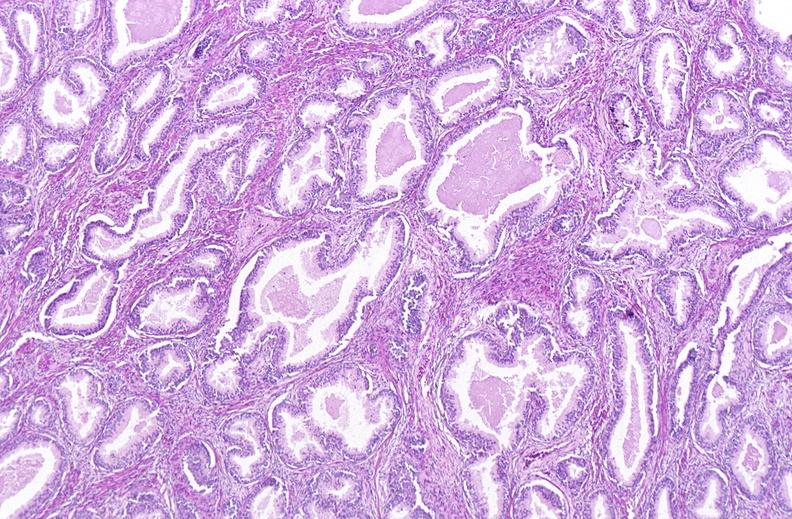does this image show prostate, benign prostatic hyperplasia?
Answer the question using a single word or phrase. Yes 